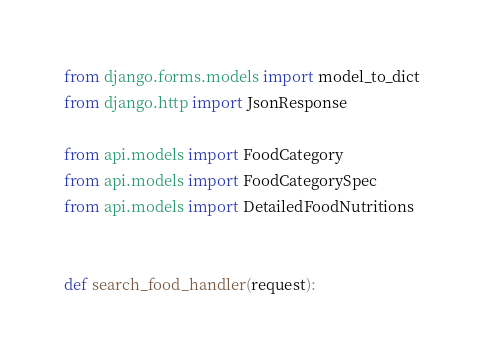Convert code to text. <code><loc_0><loc_0><loc_500><loc_500><_Python_>from django.forms.models import model_to_dict
from django.http import JsonResponse

from api.models import FoodCategory
from api.models import FoodCategorySpec
from api.models import DetailedFoodNutritions


def search_food_handler(request):</code> 